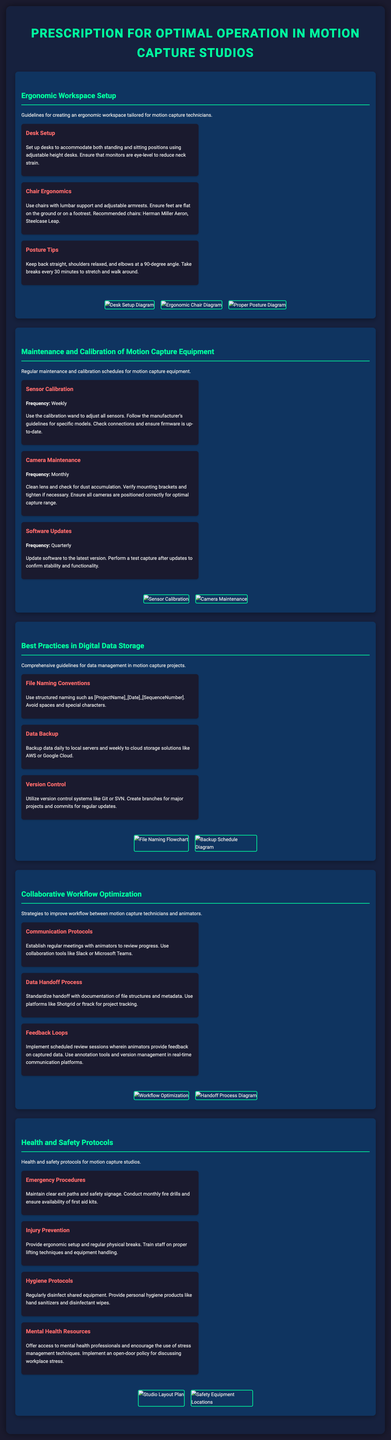What is the recommended frequency for sensor calibration? The frequency for sensor calibration is specified in the document as being weekly.
Answer: Weekly What should be used for proper chair support? The document emphasizes the use of chairs with lumbar support and adjustable armrests for ergonomic seating.
Answer: Lumbar support and adjustable armrests What is a suggested backup frequency for data? The document states that data should be backed up daily to local servers and weekly to cloud storage solutions.
Answer: Daily and weekly What tool is recommended for feedback loops? The document mentions using annotation tools and version management in real-time communication platforms.
Answer: Annotation tools How often should camera maintenance be performed? The document specifies that camera maintenance should be conducted monthly.
Answer: Monthly What is one of the ergonomic posture tips provided? The document advises keeping back straight, shoulders relaxed, and elbows at a 90-degree angle.
Answer: Keep back straight What frequency is suggested for software updates? The document indicates that software updates should occur quarterly.
Answer: Quarterly What platform is recommended for project tracking? The document recommends using platforms like Shotgrid or ftrack for project tracking.
Answer: Shotgrid or ftrack What is mentioned as a resource for mental health support? The document offers access to mental health professionals as a resource for mental health support.
Answer: Mental health professionals 